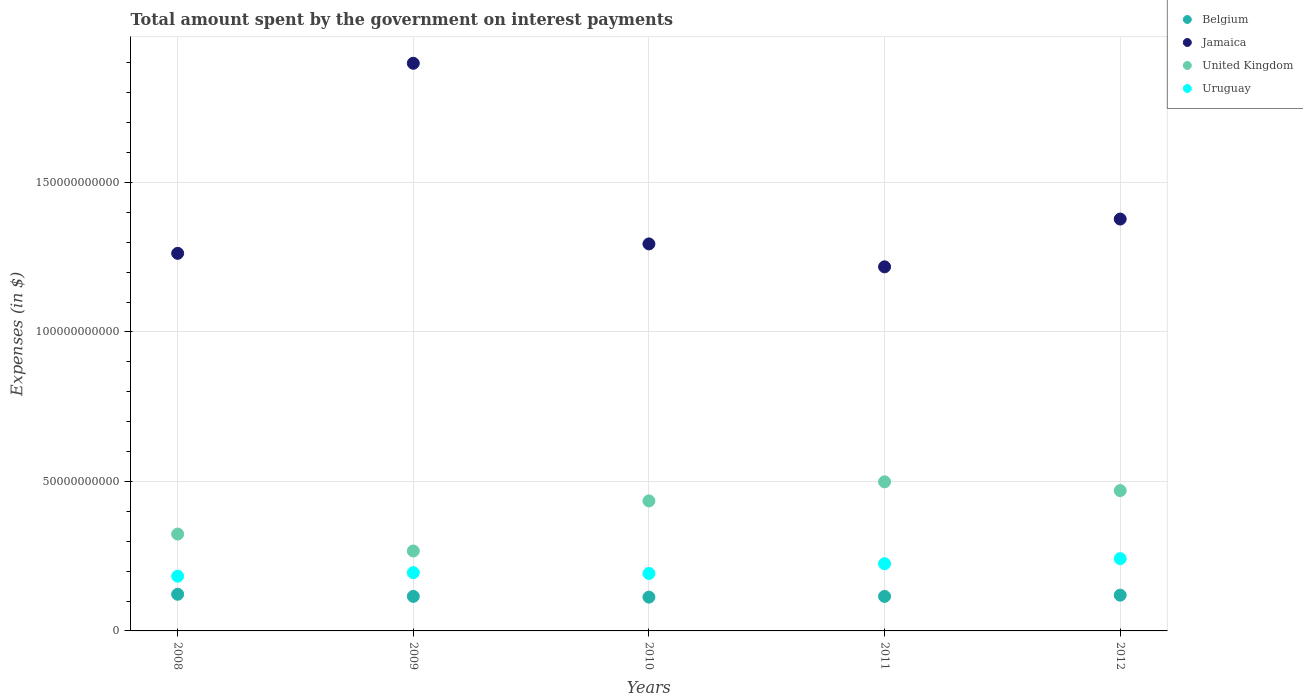How many different coloured dotlines are there?
Make the answer very short. 4. Is the number of dotlines equal to the number of legend labels?
Your response must be concise. Yes. What is the amount spent on interest payments by the government in Jamaica in 2008?
Provide a succinct answer. 1.26e+11. Across all years, what is the maximum amount spent on interest payments by the government in United Kingdom?
Keep it short and to the point. 4.99e+1. Across all years, what is the minimum amount spent on interest payments by the government in United Kingdom?
Offer a terse response. 2.67e+1. In which year was the amount spent on interest payments by the government in Uruguay maximum?
Ensure brevity in your answer.  2012. In which year was the amount spent on interest payments by the government in Uruguay minimum?
Offer a terse response. 2008. What is the total amount spent on interest payments by the government in Uruguay in the graph?
Offer a very short reply. 1.04e+11. What is the difference between the amount spent on interest payments by the government in United Kingdom in 2009 and that in 2012?
Your response must be concise. -2.02e+1. What is the difference between the amount spent on interest payments by the government in Jamaica in 2012 and the amount spent on interest payments by the government in Uruguay in 2008?
Offer a very short reply. 1.19e+11. What is the average amount spent on interest payments by the government in Uruguay per year?
Keep it short and to the point. 2.07e+1. In the year 2012, what is the difference between the amount spent on interest payments by the government in Belgium and amount spent on interest payments by the government in Uruguay?
Ensure brevity in your answer.  -1.22e+1. What is the ratio of the amount spent on interest payments by the government in Jamaica in 2009 to that in 2010?
Offer a terse response. 1.47. Is the amount spent on interest payments by the government in Jamaica in 2008 less than that in 2010?
Keep it short and to the point. Yes. Is the difference between the amount spent on interest payments by the government in Belgium in 2008 and 2012 greater than the difference between the amount spent on interest payments by the government in Uruguay in 2008 and 2012?
Make the answer very short. Yes. What is the difference between the highest and the second highest amount spent on interest payments by the government in Uruguay?
Make the answer very short. 1.70e+09. What is the difference between the highest and the lowest amount spent on interest payments by the government in Jamaica?
Offer a terse response. 6.81e+1. In how many years, is the amount spent on interest payments by the government in United Kingdom greater than the average amount spent on interest payments by the government in United Kingdom taken over all years?
Make the answer very short. 3. Is it the case that in every year, the sum of the amount spent on interest payments by the government in United Kingdom and amount spent on interest payments by the government in Belgium  is greater than the sum of amount spent on interest payments by the government in Jamaica and amount spent on interest payments by the government in Uruguay?
Offer a very short reply. No. Is it the case that in every year, the sum of the amount spent on interest payments by the government in United Kingdom and amount spent on interest payments by the government in Jamaica  is greater than the amount spent on interest payments by the government in Belgium?
Your answer should be very brief. Yes. Are the values on the major ticks of Y-axis written in scientific E-notation?
Your answer should be compact. No. Does the graph contain grids?
Your answer should be compact. Yes. How are the legend labels stacked?
Your response must be concise. Vertical. What is the title of the graph?
Give a very brief answer. Total amount spent by the government on interest payments. What is the label or title of the Y-axis?
Your answer should be very brief. Expenses (in $). What is the Expenses (in $) of Belgium in 2008?
Provide a short and direct response. 1.23e+1. What is the Expenses (in $) in Jamaica in 2008?
Your answer should be very brief. 1.26e+11. What is the Expenses (in $) of United Kingdom in 2008?
Make the answer very short. 3.24e+1. What is the Expenses (in $) in Uruguay in 2008?
Give a very brief answer. 1.83e+1. What is the Expenses (in $) of Belgium in 2009?
Your response must be concise. 1.16e+1. What is the Expenses (in $) of Jamaica in 2009?
Your response must be concise. 1.90e+11. What is the Expenses (in $) in United Kingdom in 2009?
Give a very brief answer. 2.67e+1. What is the Expenses (in $) in Uruguay in 2009?
Your response must be concise. 1.95e+1. What is the Expenses (in $) in Belgium in 2010?
Your answer should be compact. 1.13e+1. What is the Expenses (in $) in Jamaica in 2010?
Your response must be concise. 1.29e+11. What is the Expenses (in $) of United Kingdom in 2010?
Make the answer very short. 4.35e+1. What is the Expenses (in $) in Uruguay in 2010?
Your response must be concise. 1.92e+1. What is the Expenses (in $) of Belgium in 2011?
Offer a very short reply. 1.15e+1. What is the Expenses (in $) of Jamaica in 2011?
Offer a very short reply. 1.22e+11. What is the Expenses (in $) of United Kingdom in 2011?
Your response must be concise. 4.99e+1. What is the Expenses (in $) in Uruguay in 2011?
Your answer should be compact. 2.25e+1. What is the Expenses (in $) in Belgium in 2012?
Your response must be concise. 1.20e+1. What is the Expenses (in $) of Jamaica in 2012?
Your answer should be very brief. 1.38e+11. What is the Expenses (in $) in United Kingdom in 2012?
Make the answer very short. 4.69e+1. What is the Expenses (in $) in Uruguay in 2012?
Your response must be concise. 2.42e+1. Across all years, what is the maximum Expenses (in $) in Belgium?
Keep it short and to the point. 1.23e+1. Across all years, what is the maximum Expenses (in $) in Jamaica?
Offer a very short reply. 1.90e+11. Across all years, what is the maximum Expenses (in $) of United Kingdom?
Keep it short and to the point. 4.99e+1. Across all years, what is the maximum Expenses (in $) of Uruguay?
Offer a very short reply. 2.42e+1. Across all years, what is the minimum Expenses (in $) of Belgium?
Offer a terse response. 1.13e+1. Across all years, what is the minimum Expenses (in $) of Jamaica?
Give a very brief answer. 1.22e+11. Across all years, what is the minimum Expenses (in $) of United Kingdom?
Offer a terse response. 2.67e+1. Across all years, what is the minimum Expenses (in $) of Uruguay?
Ensure brevity in your answer.  1.83e+1. What is the total Expenses (in $) in Belgium in the graph?
Your answer should be compact. 5.86e+1. What is the total Expenses (in $) of Jamaica in the graph?
Ensure brevity in your answer.  7.05e+11. What is the total Expenses (in $) of United Kingdom in the graph?
Give a very brief answer. 1.99e+11. What is the total Expenses (in $) of Uruguay in the graph?
Your answer should be compact. 1.04e+11. What is the difference between the Expenses (in $) of Belgium in 2008 and that in 2009?
Your response must be concise. 7.06e+08. What is the difference between the Expenses (in $) in Jamaica in 2008 and that in 2009?
Make the answer very short. -6.36e+1. What is the difference between the Expenses (in $) of United Kingdom in 2008 and that in 2009?
Give a very brief answer. 5.66e+09. What is the difference between the Expenses (in $) in Uruguay in 2008 and that in 2009?
Keep it short and to the point. -1.18e+09. What is the difference between the Expenses (in $) in Belgium in 2008 and that in 2010?
Offer a very short reply. 9.62e+08. What is the difference between the Expenses (in $) in Jamaica in 2008 and that in 2010?
Provide a succinct answer. -3.15e+09. What is the difference between the Expenses (in $) of United Kingdom in 2008 and that in 2010?
Keep it short and to the point. -1.11e+1. What is the difference between the Expenses (in $) in Uruguay in 2008 and that in 2010?
Your response must be concise. -9.02e+08. What is the difference between the Expenses (in $) in Belgium in 2008 and that in 2011?
Keep it short and to the point. 7.14e+08. What is the difference between the Expenses (in $) in Jamaica in 2008 and that in 2011?
Provide a short and direct response. 4.51e+09. What is the difference between the Expenses (in $) of United Kingdom in 2008 and that in 2011?
Ensure brevity in your answer.  -1.75e+1. What is the difference between the Expenses (in $) of Uruguay in 2008 and that in 2011?
Keep it short and to the point. -4.17e+09. What is the difference between the Expenses (in $) in Belgium in 2008 and that in 2012?
Provide a succinct answer. 3.02e+08. What is the difference between the Expenses (in $) of Jamaica in 2008 and that in 2012?
Your answer should be very brief. -1.15e+1. What is the difference between the Expenses (in $) in United Kingdom in 2008 and that in 2012?
Keep it short and to the point. -1.45e+1. What is the difference between the Expenses (in $) of Uruguay in 2008 and that in 2012?
Provide a short and direct response. -5.86e+09. What is the difference between the Expenses (in $) in Belgium in 2009 and that in 2010?
Provide a short and direct response. 2.56e+08. What is the difference between the Expenses (in $) of Jamaica in 2009 and that in 2010?
Your answer should be very brief. 6.04e+1. What is the difference between the Expenses (in $) in United Kingdom in 2009 and that in 2010?
Offer a very short reply. -1.68e+1. What is the difference between the Expenses (in $) in Uruguay in 2009 and that in 2010?
Your answer should be very brief. 2.75e+08. What is the difference between the Expenses (in $) in Belgium in 2009 and that in 2011?
Offer a very short reply. 7.50e+06. What is the difference between the Expenses (in $) in Jamaica in 2009 and that in 2011?
Offer a terse response. 6.81e+1. What is the difference between the Expenses (in $) in United Kingdom in 2009 and that in 2011?
Make the answer very short. -2.31e+1. What is the difference between the Expenses (in $) in Uruguay in 2009 and that in 2011?
Provide a succinct answer. -2.99e+09. What is the difference between the Expenses (in $) in Belgium in 2009 and that in 2012?
Give a very brief answer. -4.04e+08. What is the difference between the Expenses (in $) in Jamaica in 2009 and that in 2012?
Your response must be concise. 5.21e+1. What is the difference between the Expenses (in $) of United Kingdom in 2009 and that in 2012?
Your answer should be compact. -2.02e+1. What is the difference between the Expenses (in $) of Uruguay in 2009 and that in 2012?
Give a very brief answer. -4.69e+09. What is the difference between the Expenses (in $) in Belgium in 2010 and that in 2011?
Give a very brief answer. -2.48e+08. What is the difference between the Expenses (in $) of Jamaica in 2010 and that in 2011?
Provide a short and direct response. 7.67e+09. What is the difference between the Expenses (in $) of United Kingdom in 2010 and that in 2011?
Your answer should be very brief. -6.38e+09. What is the difference between the Expenses (in $) of Uruguay in 2010 and that in 2011?
Offer a very short reply. -3.26e+09. What is the difference between the Expenses (in $) of Belgium in 2010 and that in 2012?
Keep it short and to the point. -6.60e+08. What is the difference between the Expenses (in $) in Jamaica in 2010 and that in 2012?
Make the answer very short. -8.32e+09. What is the difference between the Expenses (in $) in United Kingdom in 2010 and that in 2012?
Offer a terse response. -3.44e+09. What is the difference between the Expenses (in $) in Uruguay in 2010 and that in 2012?
Give a very brief answer. -4.96e+09. What is the difference between the Expenses (in $) in Belgium in 2011 and that in 2012?
Your response must be concise. -4.12e+08. What is the difference between the Expenses (in $) of Jamaica in 2011 and that in 2012?
Your answer should be very brief. -1.60e+1. What is the difference between the Expenses (in $) of United Kingdom in 2011 and that in 2012?
Offer a very short reply. 2.94e+09. What is the difference between the Expenses (in $) of Uruguay in 2011 and that in 2012?
Make the answer very short. -1.70e+09. What is the difference between the Expenses (in $) of Belgium in 2008 and the Expenses (in $) of Jamaica in 2009?
Your answer should be compact. -1.78e+11. What is the difference between the Expenses (in $) of Belgium in 2008 and the Expenses (in $) of United Kingdom in 2009?
Your answer should be compact. -1.45e+1. What is the difference between the Expenses (in $) of Belgium in 2008 and the Expenses (in $) of Uruguay in 2009?
Keep it short and to the point. -7.23e+09. What is the difference between the Expenses (in $) in Jamaica in 2008 and the Expenses (in $) in United Kingdom in 2009?
Provide a short and direct response. 9.96e+1. What is the difference between the Expenses (in $) in Jamaica in 2008 and the Expenses (in $) in Uruguay in 2009?
Your answer should be compact. 1.07e+11. What is the difference between the Expenses (in $) of United Kingdom in 2008 and the Expenses (in $) of Uruguay in 2009?
Make the answer very short. 1.29e+1. What is the difference between the Expenses (in $) of Belgium in 2008 and the Expenses (in $) of Jamaica in 2010?
Provide a short and direct response. -1.17e+11. What is the difference between the Expenses (in $) of Belgium in 2008 and the Expenses (in $) of United Kingdom in 2010?
Provide a succinct answer. -3.12e+1. What is the difference between the Expenses (in $) in Belgium in 2008 and the Expenses (in $) in Uruguay in 2010?
Give a very brief answer. -6.95e+09. What is the difference between the Expenses (in $) in Jamaica in 2008 and the Expenses (in $) in United Kingdom in 2010?
Provide a short and direct response. 8.28e+1. What is the difference between the Expenses (in $) of Jamaica in 2008 and the Expenses (in $) of Uruguay in 2010?
Ensure brevity in your answer.  1.07e+11. What is the difference between the Expenses (in $) in United Kingdom in 2008 and the Expenses (in $) in Uruguay in 2010?
Offer a terse response. 1.32e+1. What is the difference between the Expenses (in $) in Belgium in 2008 and the Expenses (in $) in Jamaica in 2011?
Your answer should be compact. -1.10e+11. What is the difference between the Expenses (in $) of Belgium in 2008 and the Expenses (in $) of United Kingdom in 2011?
Provide a short and direct response. -3.76e+1. What is the difference between the Expenses (in $) in Belgium in 2008 and the Expenses (in $) in Uruguay in 2011?
Provide a succinct answer. -1.02e+1. What is the difference between the Expenses (in $) in Jamaica in 2008 and the Expenses (in $) in United Kingdom in 2011?
Keep it short and to the point. 7.64e+1. What is the difference between the Expenses (in $) in Jamaica in 2008 and the Expenses (in $) in Uruguay in 2011?
Your answer should be very brief. 1.04e+11. What is the difference between the Expenses (in $) of United Kingdom in 2008 and the Expenses (in $) of Uruguay in 2011?
Make the answer very short. 9.92e+09. What is the difference between the Expenses (in $) of Belgium in 2008 and the Expenses (in $) of Jamaica in 2012?
Your answer should be compact. -1.25e+11. What is the difference between the Expenses (in $) in Belgium in 2008 and the Expenses (in $) in United Kingdom in 2012?
Provide a succinct answer. -3.47e+1. What is the difference between the Expenses (in $) in Belgium in 2008 and the Expenses (in $) in Uruguay in 2012?
Provide a short and direct response. -1.19e+1. What is the difference between the Expenses (in $) of Jamaica in 2008 and the Expenses (in $) of United Kingdom in 2012?
Provide a short and direct response. 7.94e+1. What is the difference between the Expenses (in $) of Jamaica in 2008 and the Expenses (in $) of Uruguay in 2012?
Keep it short and to the point. 1.02e+11. What is the difference between the Expenses (in $) of United Kingdom in 2008 and the Expenses (in $) of Uruguay in 2012?
Your answer should be very brief. 8.22e+09. What is the difference between the Expenses (in $) of Belgium in 2009 and the Expenses (in $) of Jamaica in 2010?
Your answer should be very brief. -1.18e+11. What is the difference between the Expenses (in $) in Belgium in 2009 and the Expenses (in $) in United Kingdom in 2010?
Your response must be concise. -3.19e+1. What is the difference between the Expenses (in $) in Belgium in 2009 and the Expenses (in $) in Uruguay in 2010?
Offer a terse response. -7.66e+09. What is the difference between the Expenses (in $) in Jamaica in 2009 and the Expenses (in $) in United Kingdom in 2010?
Your answer should be very brief. 1.46e+11. What is the difference between the Expenses (in $) of Jamaica in 2009 and the Expenses (in $) of Uruguay in 2010?
Offer a terse response. 1.71e+11. What is the difference between the Expenses (in $) in United Kingdom in 2009 and the Expenses (in $) in Uruguay in 2010?
Your response must be concise. 7.52e+09. What is the difference between the Expenses (in $) in Belgium in 2009 and the Expenses (in $) in Jamaica in 2011?
Give a very brief answer. -1.10e+11. What is the difference between the Expenses (in $) in Belgium in 2009 and the Expenses (in $) in United Kingdom in 2011?
Your response must be concise. -3.83e+1. What is the difference between the Expenses (in $) of Belgium in 2009 and the Expenses (in $) of Uruguay in 2011?
Ensure brevity in your answer.  -1.09e+1. What is the difference between the Expenses (in $) of Jamaica in 2009 and the Expenses (in $) of United Kingdom in 2011?
Your response must be concise. 1.40e+11. What is the difference between the Expenses (in $) in Jamaica in 2009 and the Expenses (in $) in Uruguay in 2011?
Offer a very short reply. 1.67e+11. What is the difference between the Expenses (in $) in United Kingdom in 2009 and the Expenses (in $) in Uruguay in 2011?
Ensure brevity in your answer.  4.25e+09. What is the difference between the Expenses (in $) in Belgium in 2009 and the Expenses (in $) in Jamaica in 2012?
Make the answer very short. -1.26e+11. What is the difference between the Expenses (in $) in Belgium in 2009 and the Expenses (in $) in United Kingdom in 2012?
Provide a short and direct response. -3.54e+1. What is the difference between the Expenses (in $) of Belgium in 2009 and the Expenses (in $) of Uruguay in 2012?
Make the answer very short. -1.26e+1. What is the difference between the Expenses (in $) in Jamaica in 2009 and the Expenses (in $) in United Kingdom in 2012?
Your answer should be very brief. 1.43e+11. What is the difference between the Expenses (in $) in Jamaica in 2009 and the Expenses (in $) in Uruguay in 2012?
Offer a terse response. 1.66e+11. What is the difference between the Expenses (in $) of United Kingdom in 2009 and the Expenses (in $) of Uruguay in 2012?
Provide a succinct answer. 2.56e+09. What is the difference between the Expenses (in $) of Belgium in 2010 and the Expenses (in $) of Jamaica in 2011?
Offer a very short reply. -1.10e+11. What is the difference between the Expenses (in $) in Belgium in 2010 and the Expenses (in $) in United Kingdom in 2011?
Provide a short and direct response. -3.86e+1. What is the difference between the Expenses (in $) of Belgium in 2010 and the Expenses (in $) of Uruguay in 2011?
Give a very brief answer. -1.12e+1. What is the difference between the Expenses (in $) in Jamaica in 2010 and the Expenses (in $) in United Kingdom in 2011?
Provide a succinct answer. 7.96e+1. What is the difference between the Expenses (in $) in Jamaica in 2010 and the Expenses (in $) in Uruguay in 2011?
Offer a very short reply. 1.07e+11. What is the difference between the Expenses (in $) of United Kingdom in 2010 and the Expenses (in $) of Uruguay in 2011?
Ensure brevity in your answer.  2.10e+1. What is the difference between the Expenses (in $) of Belgium in 2010 and the Expenses (in $) of Jamaica in 2012?
Make the answer very short. -1.26e+11. What is the difference between the Expenses (in $) of Belgium in 2010 and the Expenses (in $) of United Kingdom in 2012?
Provide a short and direct response. -3.56e+1. What is the difference between the Expenses (in $) of Belgium in 2010 and the Expenses (in $) of Uruguay in 2012?
Ensure brevity in your answer.  -1.29e+1. What is the difference between the Expenses (in $) in Jamaica in 2010 and the Expenses (in $) in United Kingdom in 2012?
Make the answer very short. 8.25e+1. What is the difference between the Expenses (in $) of Jamaica in 2010 and the Expenses (in $) of Uruguay in 2012?
Make the answer very short. 1.05e+11. What is the difference between the Expenses (in $) of United Kingdom in 2010 and the Expenses (in $) of Uruguay in 2012?
Offer a very short reply. 1.93e+1. What is the difference between the Expenses (in $) in Belgium in 2011 and the Expenses (in $) in Jamaica in 2012?
Your answer should be very brief. -1.26e+11. What is the difference between the Expenses (in $) of Belgium in 2011 and the Expenses (in $) of United Kingdom in 2012?
Keep it short and to the point. -3.54e+1. What is the difference between the Expenses (in $) in Belgium in 2011 and the Expenses (in $) in Uruguay in 2012?
Make the answer very short. -1.26e+1. What is the difference between the Expenses (in $) of Jamaica in 2011 and the Expenses (in $) of United Kingdom in 2012?
Your answer should be very brief. 7.48e+1. What is the difference between the Expenses (in $) of Jamaica in 2011 and the Expenses (in $) of Uruguay in 2012?
Make the answer very short. 9.76e+1. What is the difference between the Expenses (in $) in United Kingdom in 2011 and the Expenses (in $) in Uruguay in 2012?
Provide a succinct answer. 2.57e+1. What is the average Expenses (in $) in Belgium per year?
Keep it short and to the point. 1.17e+1. What is the average Expenses (in $) in Jamaica per year?
Provide a succinct answer. 1.41e+11. What is the average Expenses (in $) in United Kingdom per year?
Your answer should be very brief. 3.99e+1. What is the average Expenses (in $) of Uruguay per year?
Your answer should be compact. 2.07e+1. In the year 2008, what is the difference between the Expenses (in $) of Belgium and Expenses (in $) of Jamaica?
Give a very brief answer. -1.14e+11. In the year 2008, what is the difference between the Expenses (in $) in Belgium and Expenses (in $) in United Kingdom?
Your answer should be compact. -2.01e+1. In the year 2008, what is the difference between the Expenses (in $) of Belgium and Expenses (in $) of Uruguay?
Your response must be concise. -6.05e+09. In the year 2008, what is the difference between the Expenses (in $) of Jamaica and Expenses (in $) of United Kingdom?
Provide a short and direct response. 9.39e+1. In the year 2008, what is the difference between the Expenses (in $) in Jamaica and Expenses (in $) in Uruguay?
Ensure brevity in your answer.  1.08e+11. In the year 2008, what is the difference between the Expenses (in $) of United Kingdom and Expenses (in $) of Uruguay?
Your response must be concise. 1.41e+1. In the year 2009, what is the difference between the Expenses (in $) in Belgium and Expenses (in $) in Jamaica?
Provide a short and direct response. -1.78e+11. In the year 2009, what is the difference between the Expenses (in $) in Belgium and Expenses (in $) in United Kingdom?
Give a very brief answer. -1.52e+1. In the year 2009, what is the difference between the Expenses (in $) in Belgium and Expenses (in $) in Uruguay?
Your answer should be compact. -7.93e+09. In the year 2009, what is the difference between the Expenses (in $) of Jamaica and Expenses (in $) of United Kingdom?
Offer a terse response. 1.63e+11. In the year 2009, what is the difference between the Expenses (in $) in Jamaica and Expenses (in $) in Uruguay?
Your answer should be compact. 1.70e+11. In the year 2009, what is the difference between the Expenses (in $) in United Kingdom and Expenses (in $) in Uruguay?
Ensure brevity in your answer.  7.24e+09. In the year 2010, what is the difference between the Expenses (in $) in Belgium and Expenses (in $) in Jamaica?
Make the answer very short. -1.18e+11. In the year 2010, what is the difference between the Expenses (in $) of Belgium and Expenses (in $) of United Kingdom?
Offer a terse response. -3.22e+1. In the year 2010, what is the difference between the Expenses (in $) in Belgium and Expenses (in $) in Uruguay?
Provide a succinct answer. -7.91e+09. In the year 2010, what is the difference between the Expenses (in $) of Jamaica and Expenses (in $) of United Kingdom?
Provide a short and direct response. 8.60e+1. In the year 2010, what is the difference between the Expenses (in $) in Jamaica and Expenses (in $) in Uruguay?
Offer a terse response. 1.10e+11. In the year 2010, what is the difference between the Expenses (in $) of United Kingdom and Expenses (in $) of Uruguay?
Ensure brevity in your answer.  2.43e+1. In the year 2011, what is the difference between the Expenses (in $) in Belgium and Expenses (in $) in Jamaica?
Your response must be concise. -1.10e+11. In the year 2011, what is the difference between the Expenses (in $) in Belgium and Expenses (in $) in United Kingdom?
Keep it short and to the point. -3.83e+1. In the year 2011, what is the difference between the Expenses (in $) of Belgium and Expenses (in $) of Uruguay?
Provide a short and direct response. -1.09e+1. In the year 2011, what is the difference between the Expenses (in $) in Jamaica and Expenses (in $) in United Kingdom?
Provide a short and direct response. 7.19e+1. In the year 2011, what is the difference between the Expenses (in $) in Jamaica and Expenses (in $) in Uruguay?
Your answer should be very brief. 9.93e+1. In the year 2011, what is the difference between the Expenses (in $) in United Kingdom and Expenses (in $) in Uruguay?
Your response must be concise. 2.74e+1. In the year 2012, what is the difference between the Expenses (in $) of Belgium and Expenses (in $) of Jamaica?
Provide a short and direct response. -1.26e+11. In the year 2012, what is the difference between the Expenses (in $) in Belgium and Expenses (in $) in United Kingdom?
Keep it short and to the point. -3.50e+1. In the year 2012, what is the difference between the Expenses (in $) in Belgium and Expenses (in $) in Uruguay?
Your response must be concise. -1.22e+1. In the year 2012, what is the difference between the Expenses (in $) of Jamaica and Expenses (in $) of United Kingdom?
Your answer should be very brief. 9.08e+1. In the year 2012, what is the difference between the Expenses (in $) in Jamaica and Expenses (in $) in Uruguay?
Your response must be concise. 1.14e+11. In the year 2012, what is the difference between the Expenses (in $) of United Kingdom and Expenses (in $) of Uruguay?
Offer a very short reply. 2.27e+1. What is the ratio of the Expenses (in $) in Belgium in 2008 to that in 2009?
Your answer should be compact. 1.06. What is the ratio of the Expenses (in $) of Jamaica in 2008 to that in 2009?
Keep it short and to the point. 0.67. What is the ratio of the Expenses (in $) of United Kingdom in 2008 to that in 2009?
Your answer should be compact. 1.21. What is the ratio of the Expenses (in $) of Uruguay in 2008 to that in 2009?
Give a very brief answer. 0.94. What is the ratio of the Expenses (in $) in Belgium in 2008 to that in 2010?
Your answer should be compact. 1.09. What is the ratio of the Expenses (in $) in Jamaica in 2008 to that in 2010?
Your response must be concise. 0.98. What is the ratio of the Expenses (in $) in United Kingdom in 2008 to that in 2010?
Ensure brevity in your answer.  0.74. What is the ratio of the Expenses (in $) of Uruguay in 2008 to that in 2010?
Give a very brief answer. 0.95. What is the ratio of the Expenses (in $) in Belgium in 2008 to that in 2011?
Give a very brief answer. 1.06. What is the ratio of the Expenses (in $) in Jamaica in 2008 to that in 2011?
Your answer should be very brief. 1.04. What is the ratio of the Expenses (in $) of United Kingdom in 2008 to that in 2011?
Ensure brevity in your answer.  0.65. What is the ratio of the Expenses (in $) in Uruguay in 2008 to that in 2011?
Keep it short and to the point. 0.81. What is the ratio of the Expenses (in $) in Belgium in 2008 to that in 2012?
Keep it short and to the point. 1.03. What is the ratio of the Expenses (in $) in Jamaica in 2008 to that in 2012?
Give a very brief answer. 0.92. What is the ratio of the Expenses (in $) in United Kingdom in 2008 to that in 2012?
Offer a very short reply. 0.69. What is the ratio of the Expenses (in $) in Uruguay in 2008 to that in 2012?
Your response must be concise. 0.76. What is the ratio of the Expenses (in $) in Belgium in 2009 to that in 2010?
Your answer should be very brief. 1.02. What is the ratio of the Expenses (in $) in Jamaica in 2009 to that in 2010?
Provide a short and direct response. 1.47. What is the ratio of the Expenses (in $) of United Kingdom in 2009 to that in 2010?
Your answer should be compact. 0.61. What is the ratio of the Expenses (in $) in Uruguay in 2009 to that in 2010?
Make the answer very short. 1.01. What is the ratio of the Expenses (in $) of Jamaica in 2009 to that in 2011?
Make the answer very short. 1.56. What is the ratio of the Expenses (in $) of United Kingdom in 2009 to that in 2011?
Your response must be concise. 0.54. What is the ratio of the Expenses (in $) in Uruguay in 2009 to that in 2011?
Keep it short and to the point. 0.87. What is the ratio of the Expenses (in $) of Belgium in 2009 to that in 2012?
Offer a very short reply. 0.97. What is the ratio of the Expenses (in $) in Jamaica in 2009 to that in 2012?
Offer a terse response. 1.38. What is the ratio of the Expenses (in $) in United Kingdom in 2009 to that in 2012?
Your answer should be compact. 0.57. What is the ratio of the Expenses (in $) of Uruguay in 2009 to that in 2012?
Offer a very short reply. 0.81. What is the ratio of the Expenses (in $) in Belgium in 2010 to that in 2011?
Provide a short and direct response. 0.98. What is the ratio of the Expenses (in $) of Jamaica in 2010 to that in 2011?
Ensure brevity in your answer.  1.06. What is the ratio of the Expenses (in $) in United Kingdom in 2010 to that in 2011?
Give a very brief answer. 0.87. What is the ratio of the Expenses (in $) of Uruguay in 2010 to that in 2011?
Offer a very short reply. 0.85. What is the ratio of the Expenses (in $) in Belgium in 2010 to that in 2012?
Provide a succinct answer. 0.94. What is the ratio of the Expenses (in $) of Jamaica in 2010 to that in 2012?
Provide a succinct answer. 0.94. What is the ratio of the Expenses (in $) in United Kingdom in 2010 to that in 2012?
Offer a terse response. 0.93. What is the ratio of the Expenses (in $) of Uruguay in 2010 to that in 2012?
Provide a succinct answer. 0.79. What is the ratio of the Expenses (in $) of Belgium in 2011 to that in 2012?
Provide a short and direct response. 0.97. What is the ratio of the Expenses (in $) in Jamaica in 2011 to that in 2012?
Your response must be concise. 0.88. What is the ratio of the Expenses (in $) in United Kingdom in 2011 to that in 2012?
Keep it short and to the point. 1.06. What is the ratio of the Expenses (in $) of Uruguay in 2011 to that in 2012?
Give a very brief answer. 0.93. What is the difference between the highest and the second highest Expenses (in $) in Belgium?
Your answer should be very brief. 3.02e+08. What is the difference between the highest and the second highest Expenses (in $) in Jamaica?
Give a very brief answer. 5.21e+1. What is the difference between the highest and the second highest Expenses (in $) in United Kingdom?
Your answer should be very brief. 2.94e+09. What is the difference between the highest and the second highest Expenses (in $) in Uruguay?
Give a very brief answer. 1.70e+09. What is the difference between the highest and the lowest Expenses (in $) in Belgium?
Offer a terse response. 9.62e+08. What is the difference between the highest and the lowest Expenses (in $) of Jamaica?
Ensure brevity in your answer.  6.81e+1. What is the difference between the highest and the lowest Expenses (in $) in United Kingdom?
Provide a short and direct response. 2.31e+1. What is the difference between the highest and the lowest Expenses (in $) in Uruguay?
Your answer should be compact. 5.86e+09. 